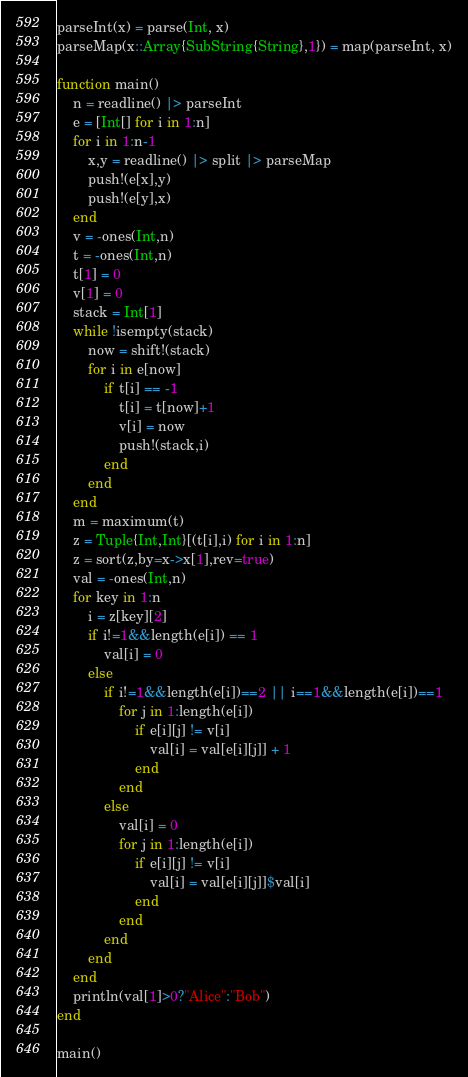<code> <loc_0><loc_0><loc_500><loc_500><_Julia_>parseInt(x) = parse(Int, x)
parseMap(x::Array{SubString{String},1}) = map(parseInt, x)

function main()
	n = readline() |> parseInt
	e = [Int[] for i in 1:n]
	for i in 1:n-1
		x,y = readline() |> split |> parseMap
		push!(e[x],y)
		push!(e[y],x)
	end
	v = -ones(Int,n)
	t = -ones(Int,n)
	t[1] = 0
	v[1] = 0
	stack = Int[1]
	while !isempty(stack)
		now = shift!(stack)
		for i in e[now]
			if t[i] == -1
				t[i] = t[now]+1
				v[i] = now
				push!(stack,i)
			end
		end
	end
	m = maximum(t)
	z = Tuple{Int,Int}[(t[i],i) for i in 1:n]
	z = sort(z,by=x->x[1],rev=true)
	val = -ones(Int,n)
	for key in 1:n
		i = z[key][2]
		if i!=1&&length(e[i]) == 1
			val[i] = 0
		else
			if i!=1&&length(e[i])==2 || i==1&&length(e[i])==1
				for j in 1:length(e[i])
					if e[i][j] != v[i]
						val[i] = val[e[i][j]] + 1
					end
				end
			else
				val[i] = 0
				for j in 1:length(e[i])
					if e[i][j] != v[i]
						val[i] = val[e[i][j]]$val[i]
					end
				end
			end
		end
	end
	println(val[1]>0?"Alice":"Bob")
end

main()
</code> 